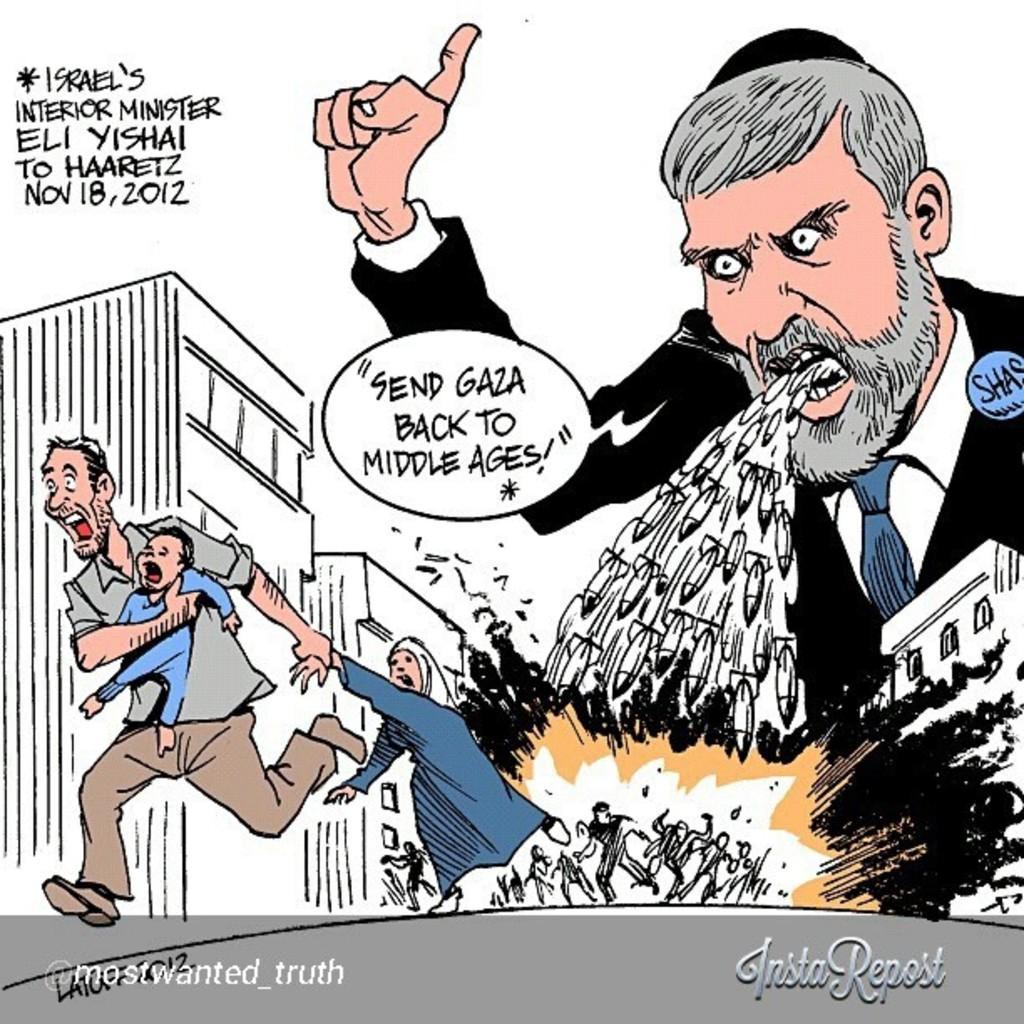Describe this image in one or two sentences. In this picture it looks like a poster in this image there are some persons and there is some text, buildings. And at the bottom and top of the image there is some text. 